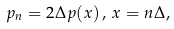<formula> <loc_0><loc_0><loc_500><loc_500>p _ { n } = 2 \Delta p ( x ) \, , \, x = n \Delta ,</formula> 